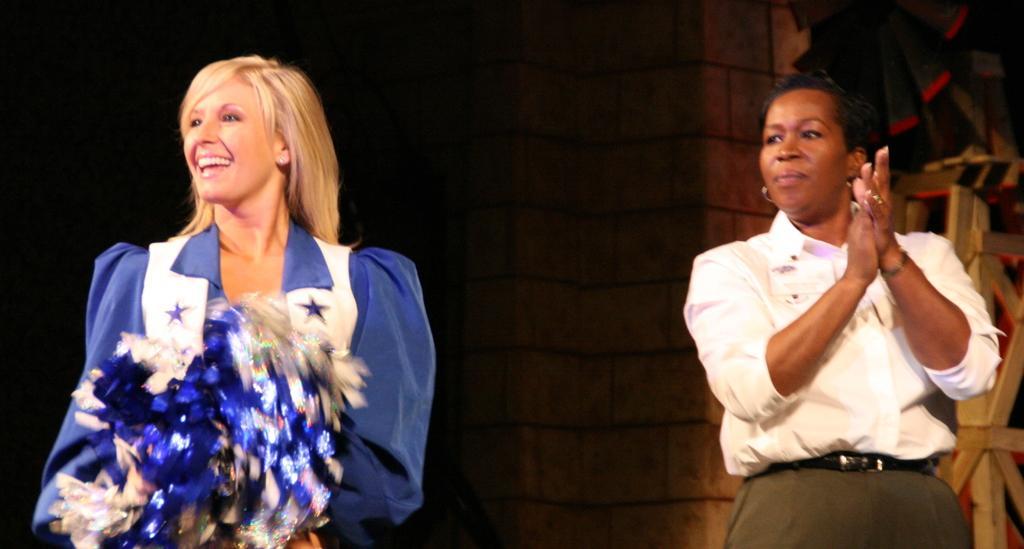Describe this image in one or two sentences. In the image two persons are standing and smiling. Behind them there is a wall. 